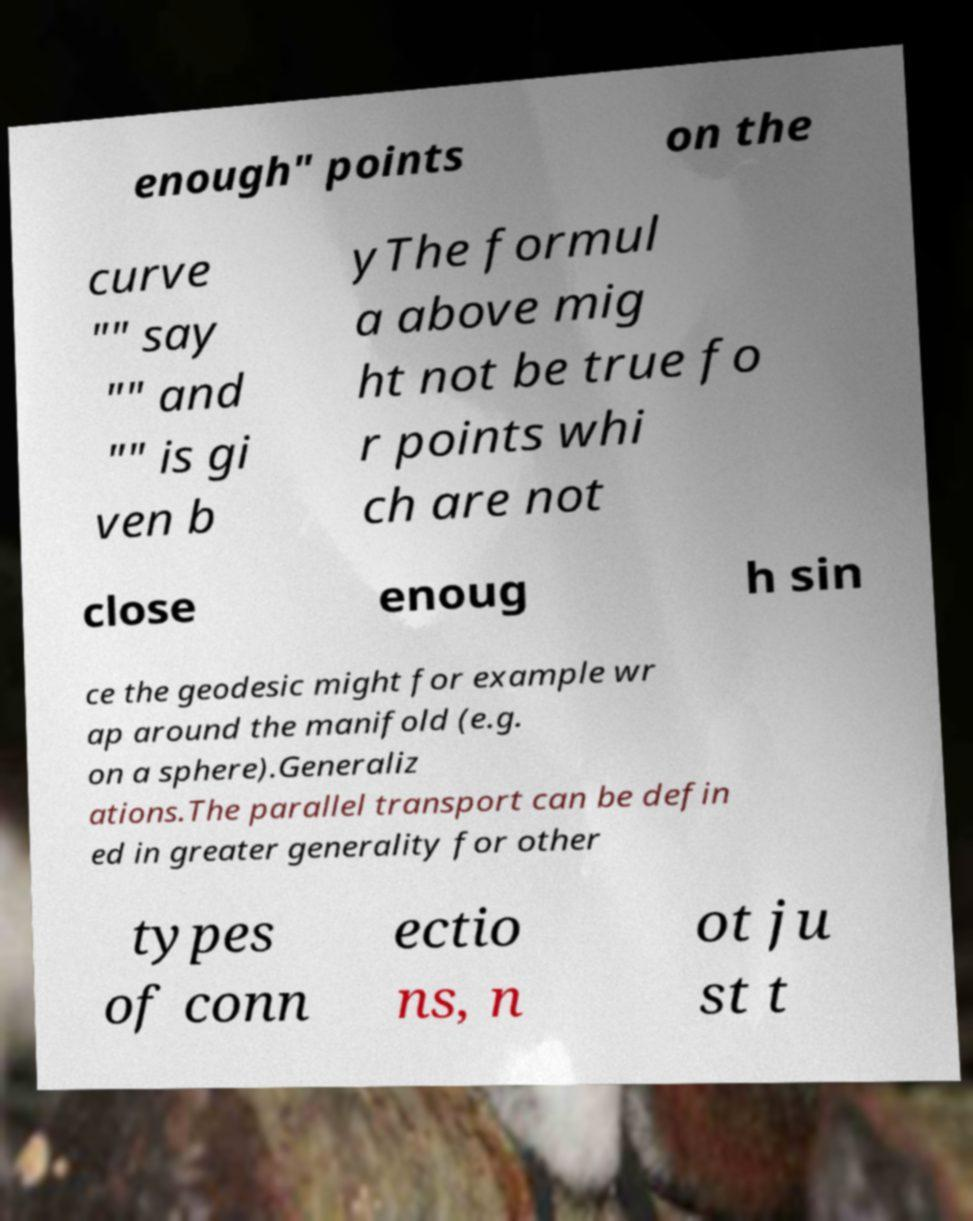There's text embedded in this image that I need extracted. Can you transcribe it verbatim? enough" points on the curve "" say "" and "" is gi ven b yThe formul a above mig ht not be true fo r points whi ch are not close enoug h sin ce the geodesic might for example wr ap around the manifold (e.g. on a sphere).Generaliz ations.The parallel transport can be defin ed in greater generality for other types of conn ectio ns, n ot ju st t 